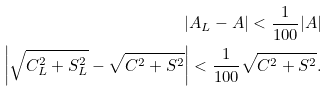Convert formula to latex. <formula><loc_0><loc_0><loc_500><loc_500>| A _ { L } - A | < \frac { 1 } { 1 0 0 } | A | \\ \left | \sqrt { C _ { L } ^ { 2 } + S _ { L } ^ { 2 } } - \sqrt { C ^ { 2 } + S ^ { 2 } } \right | < \frac { 1 } { 1 0 0 } \sqrt { C ^ { 2 } + S ^ { 2 } } .</formula> 